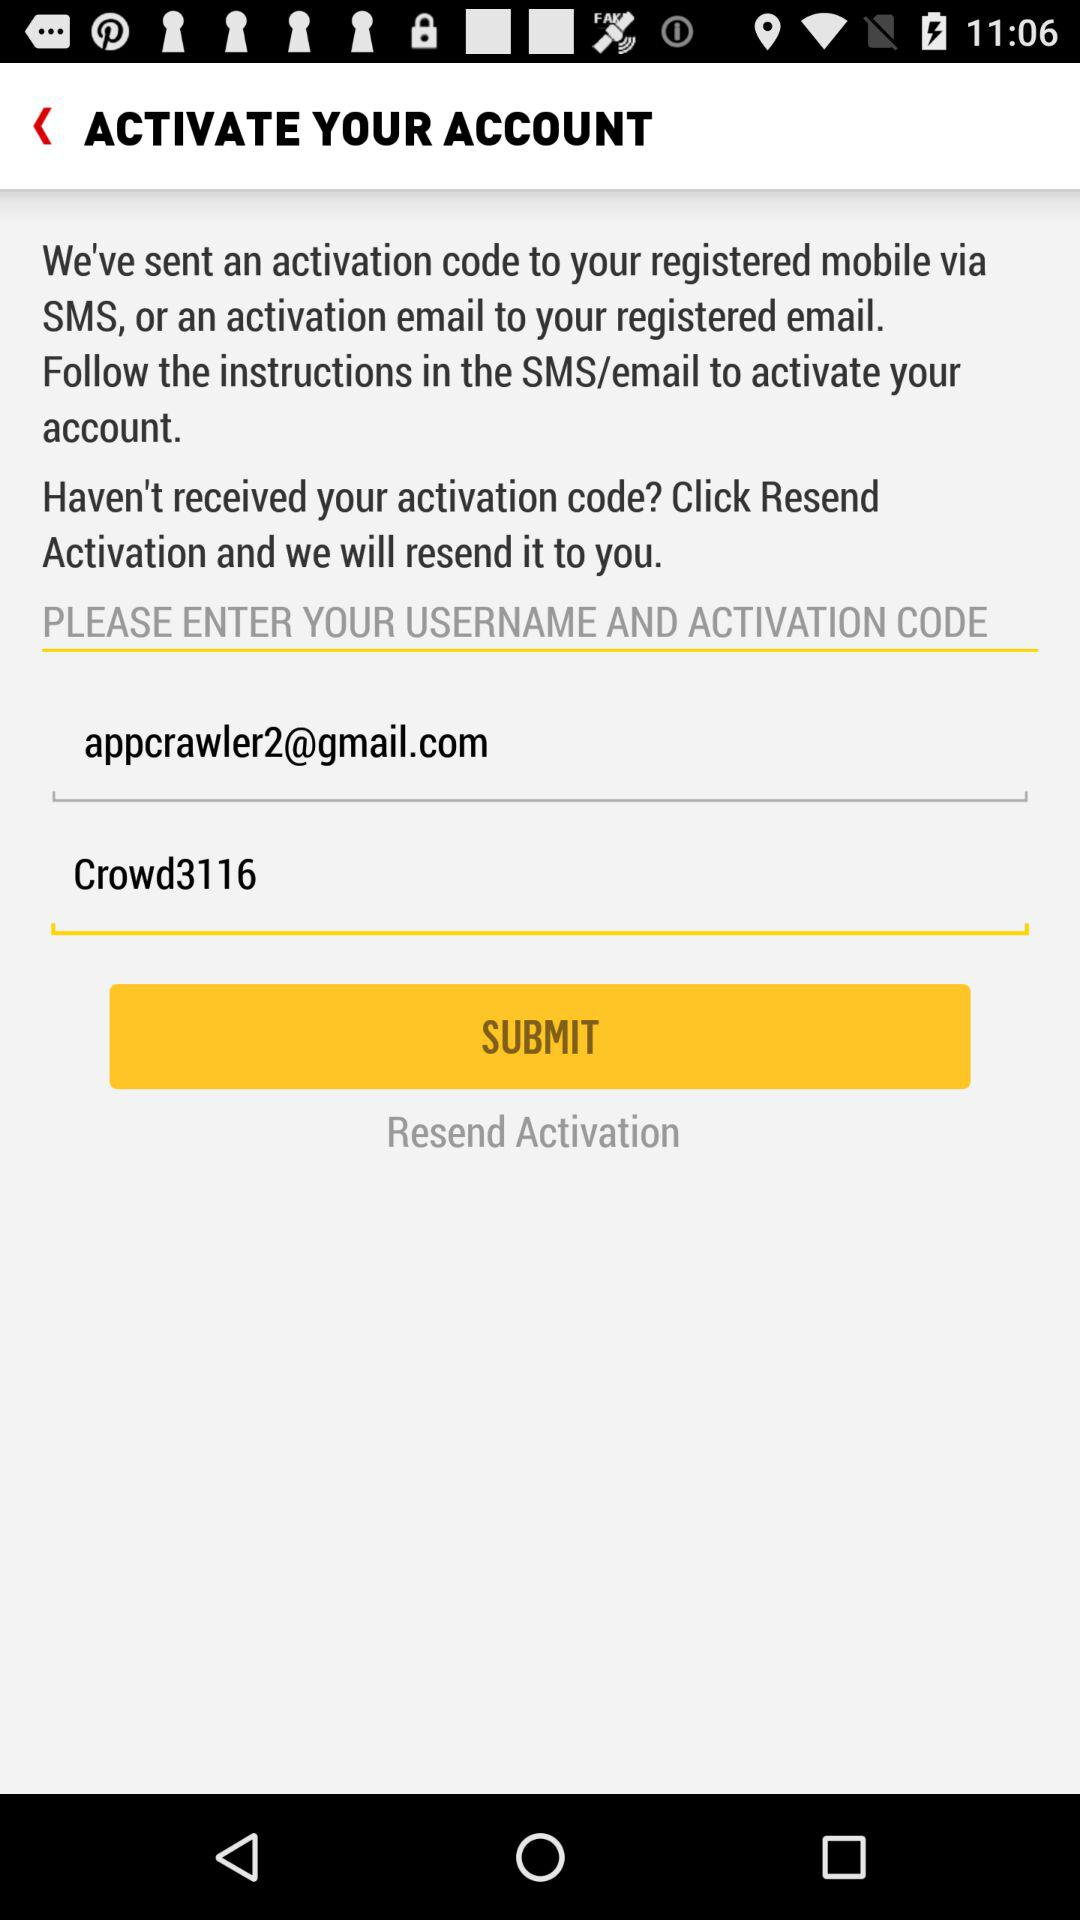What's the activation code? The activation code is "Crowd3116". 